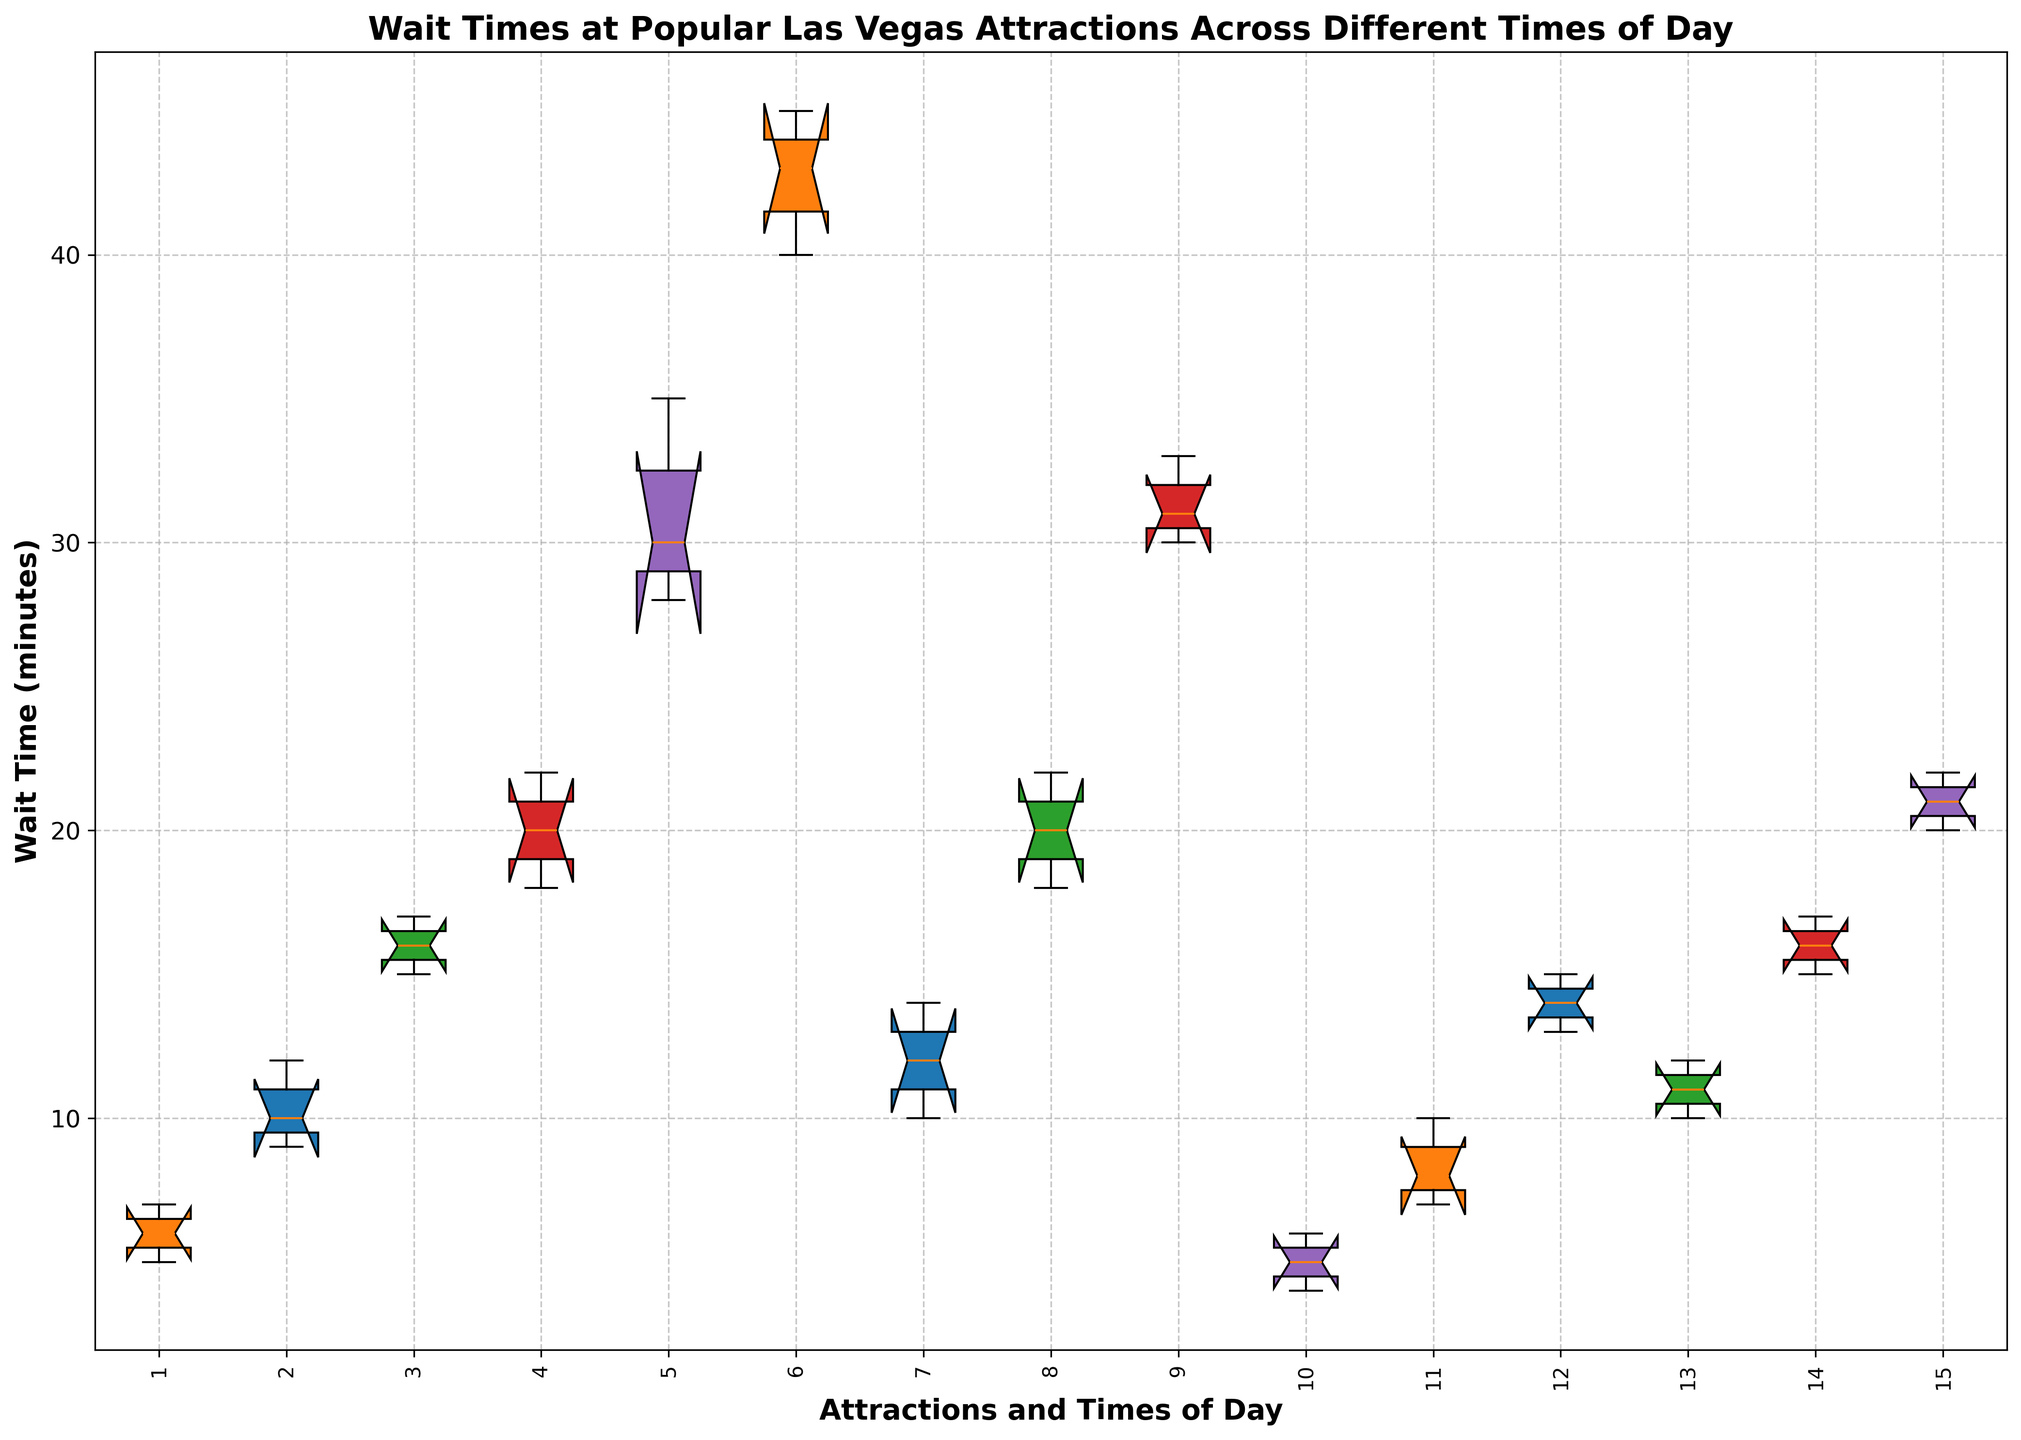What's the median wait time at Bellagio Fountains in the morning? Look at the Bellagio Fountains (Morning) box and find the line inside the box, which represents the median.
Answer: 6 Which attraction has the highest median wait time in the evening? Find the boxes marked "Evening" and check which has the highest middle line (median). The High Roller has the highest median in the evening.
Answer: High Roller Compare the average wait times at The Stratosphere between morning and afternoon. Calculate the average of the wait times for The Stratosphere in both morning and afternoon. Morning: (12+10+14)/3 = 12, Afternoon: (20+22+18)/3 = 20
Answer: Morning: 12, Afternoon: 20 Which attraction exhibits the greatest range in wait times during the morning? Determine the range (max - min) for morning wait times for each attraction and compare them. The High Roller has the greatest range, with a difference from 22 to 18.
Answer: High Roller How does the wait time for Bellagio Fountains in the afternoon compare to High Roller in the afternoon? Compare the median line of Bellagio Fountains (Afternoon) and High Roller (Afternoon). High Roller has higher median wait times.
Answer: High Roller is higher What time of day generally has the highest wait times across all attractions? Look at the medians of all times of day for all attractions and see which time has the highest overall medians. Evening has generally higher wait times.
Answer: Evening Which attraction has the lowest wait time during the morning? Identify the attraction with the lowest bottom whisker for morning time. Fremont Street Experience has the lowest wait time in the morning.
Answer: Fremont Street Experience Compare the dispersion of wait times for The Venetian Gondola Rides between morning and evening. The dispersion is given by the length of the boxes and whiskers. In the evening, the dispersion is larger than in the morning.
Answer: Evening has larger dispersion What's the interquartile range (IQR) of wait times for the Fremont Street Experience in the afternoon? IQR is the range between the first and third quartile. For Fremont Street Experience (Afternoon), it’s the distance between the bottom and top of the box. The IQR is from 7 to 10, so the IQR is 10-7.
Answer: 3 Which time of day shows the least variance in wait times for The Stratosphere? The variance is represented by the width of the boxes. In the morning, the box for The Stratosphere is narrower compared to afternoon and evening.
Answer: Morning 